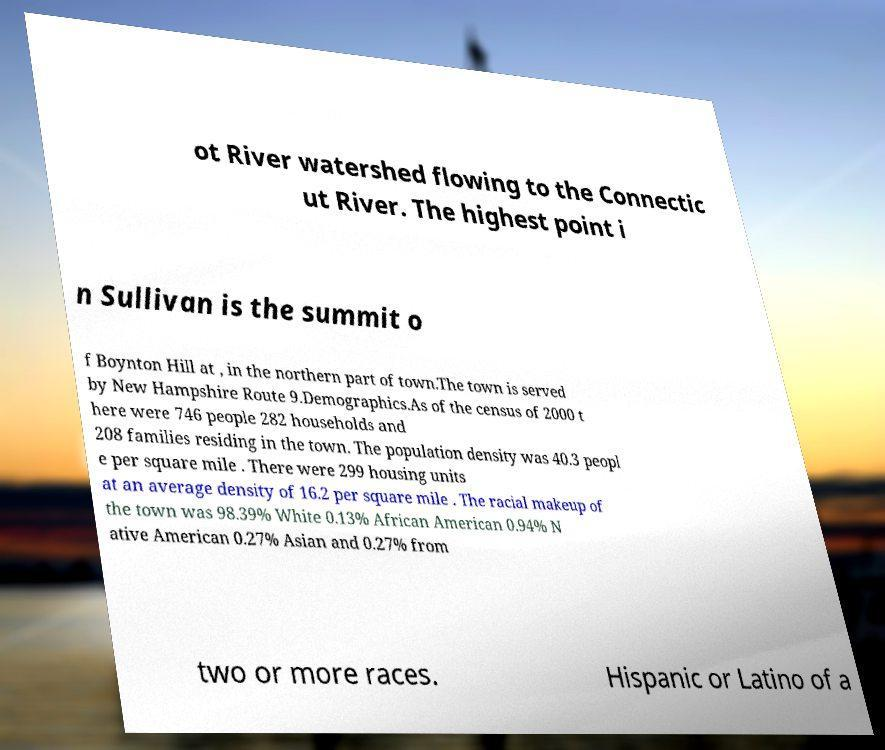Please identify and transcribe the text found in this image. ot River watershed flowing to the Connectic ut River. The highest point i n Sullivan is the summit o f Boynton Hill at , in the northern part of town.The town is served by New Hampshire Route 9.Demographics.As of the census of 2000 t here were 746 people 282 households and 208 families residing in the town. The population density was 40.3 peopl e per square mile . There were 299 housing units at an average density of 16.2 per square mile . The racial makeup of the town was 98.39% White 0.13% African American 0.94% N ative American 0.27% Asian and 0.27% from two or more races. Hispanic or Latino of a 